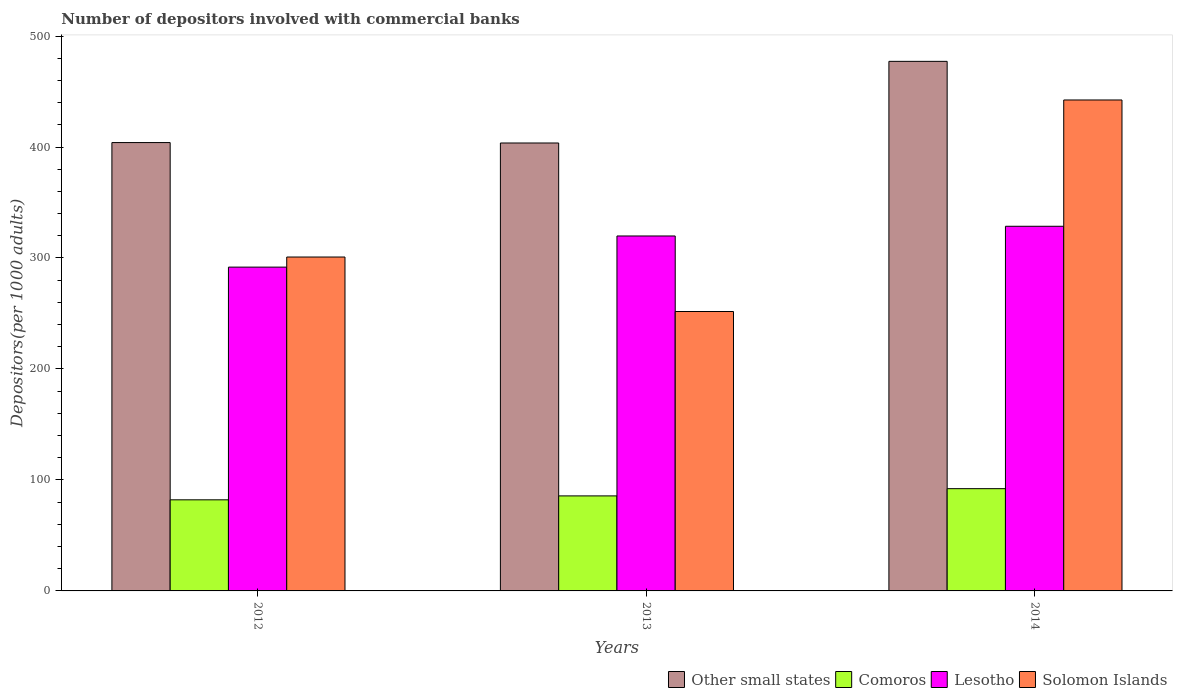Are the number of bars per tick equal to the number of legend labels?
Keep it short and to the point. Yes. Are the number of bars on each tick of the X-axis equal?
Your answer should be very brief. Yes. What is the label of the 2nd group of bars from the left?
Keep it short and to the point. 2013. In how many cases, is the number of bars for a given year not equal to the number of legend labels?
Keep it short and to the point. 0. What is the number of depositors involved with commercial banks in Solomon Islands in 2012?
Keep it short and to the point. 300.87. Across all years, what is the maximum number of depositors involved with commercial banks in Solomon Islands?
Provide a succinct answer. 442.39. Across all years, what is the minimum number of depositors involved with commercial banks in Lesotho?
Give a very brief answer. 291.78. In which year was the number of depositors involved with commercial banks in Comoros maximum?
Offer a very short reply. 2014. In which year was the number of depositors involved with commercial banks in Other small states minimum?
Offer a very short reply. 2013. What is the total number of depositors involved with commercial banks in Lesotho in the graph?
Give a very brief answer. 940.21. What is the difference between the number of depositors involved with commercial banks in Comoros in 2013 and that in 2014?
Give a very brief answer. -6.52. What is the difference between the number of depositors involved with commercial banks in Solomon Islands in 2012 and the number of depositors involved with commercial banks in Lesotho in 2013?
Provide a succinct answer. -18.97. What is the average number of depositors involved with commercial banks in Other small states per year?
Your answer should be compact. 428.28. In the year 2013, what is the difference between the number of depositors involved with commercial banks in Solomon Islands and number of depositors involved with commercial banks in Other small states?
Your response must be concise. -151.85. What is the ratio of the number of depositors involved with commercial banks in Lesotho in 2012 to that in 2014?
Your answer should be compact. 0.89. Is the number of depositors involved with commercial banks in Comoros in 2012 less than that in 2013?
Your answer should be compact. Yes. Is the difference between the number of depositors involved with commercial banks in Solomon Islands in 2013 and 2014 greater than the difference between the number of depositors involved with commercial banks in Other small states in 2013 and 2014?
Provide a short and direct response. No. What is the difference between the highest and the second highest number of depositors involved with commercial banks in Other small states?
Provide a short and direct response. 73.18. What is the difference between the highest and the lowest number of depositors involved with commercial banks in Other small states?
Offer a terse response. 73.56. Is the sum of the number of depositors involved with commercial banks in Comoros in 2012 and 2014 greater than the maximum number of depositors involved with commercial banks in Lesotho across all years?
Your response must be concise. No. Is it the case that in every year, the sum of the number of depositors involved with commercial banks in Other small states and number of depositors involved with commercial banks in Lesotho is greater than the sum of number of depositors involved with commercial banks in Solomon Islands and number of depositors involved with commercial banks in Comoros?
Provide a succinct answer. No. What does the 4th bar from the left in 2014 represents?
Provide a succinct answer. Solomon Islands. What does the 1st bar from the right in 2013 represents?
Ensure brevity in your answer.  Solomon Islands. Are all the bars in the graph horizontal?
Provide a succinct answer. No. How many years are there in the graph?
Your answer should be compact. 3. What is the difference between two consecutive major ticks on the Y-axis?
Provide a short and direct response. 100. Does the graph contain grids?
Your response must be concise. No. Where does the legend appear in the graph?
Offer a terse response. Bottom right. How many legend labels are there?
Your answer should be very brief. 4. How are the legend labels stacked?
Make the answer very short. Horizontal. What is the title of the graph?
Ensure brevity in your answer.  Number of depositors involved with commercial banks. What is the label or title of the Y-axis?
Provide a succinct answer. Depositors(per 1000 adults). What is the Depositors(per 1000 adults) of Other small states in 2012?
Offer a very short reply. 404.02. What is the Depositors(per 1000 adults) of Comoros in 2012?
Ensure brevity in your answer.  82.09. What is the Depositors(per 1000 adults) of Lesotho in 2012?
Ensure brevity in your answer.  291.78. What is the Depositors(per 1000 adults) of Solomon Islands in 2012?
Offer a very short reply. 300.87. What is the Depositors(per 1000 adults) in Other small states in 2013?
Give a very brief answer. 403.64. What is the Depositors(per 1000 adults) of Comoros in 2013?
Your response must be concise. 85.63. What is the Depositors(per 1000 adults) in Lesotho in 2013?
Make the answer very short. 319.84. What is the Depositors(per 1000 adults) in Solomon Islands in 2013?
Provide a succinct answer. 251.79. What is the Depositors(per 1000 adults) of Other small states in 2014?
Keep it short and to the point. 477.2. What is the Depositors(per 1000 adults) of Comoros in 2014?
Your response must be concise. 92.15. What is the Depositors(per 1000 adults) in Lesotho in 2014?
Offer a very short reply. 328.59. What is the Depositors(per 1000 adults) of Solomon Islands in 2014?
Make the answer very short. 442.39. Across all years, what is the maximum Depositors(per 1000 adults) of Other small states?
Provide a short and direct response. 477.2. Across all years, what is the maximum Depositors(per 1000 adults) in Comoros?
Ensure brevity in your answer.  92.15. Across all years, what is the maximum Depositors(per 1000 adults) in Lesotho?
Your answer should be compact. 328.59. Across all years, what is the maximum Depositors(per 1000 adults) of Solomon Islands?
Your answer should be very brief. 442.39. Across all years, what is the minimum Depositors(per 1000 adults) of Other small states?
Give a very brief answer. 403.64. Across all years, what is the minimum Depositors(per 1000 adults) of Comoros?
Provide a short and direct response. 82.09. Across all years, what is the minimum Depositors(per 1000 adults) in Lesotho?
Give a very brief answer. 291.78. Across all years, what is the minimum Depositors(per 1000 adults) of Solomon Islands?
Provide a succinct answer. 251.79. What is the total Depositors(per 1000 adults) of Other small states in the graph?
Your answer should be compact. 1284.85. What is the total Depositors(per 1000 adults) of Comoros in the graph?
Keep it short and to the point. 259.87. What is the total Depositors(per 1000 adults) in Lesotho in the graph?
Your answer should be compact. 940.21. What is the total Depositors(per 1000 adults) of Solomon Islands in the graph?
Your answer should be very brief. 995.05. What is the difference between the Depositors(per 1000 adults) of Other small states in 2012 and that in 2013?
Make the answer very short. 0.38. What is the difference between the Depositors(per 1000 adults) in Comoros in 2012 and that in 2013?
Offer a very short reply. -3.54. What is the difference between the Depositors(per 1000 adults) of Lesotho in 2012 and that in 2013?
Keep it short and to the point. -28.06. What is the difference between the Depositors(per 1000 adults) of Solomon Islands in 2012 and that in 2013?
Your response must be concise. 49.08. What is the difference between the Depositors(per 1000 adults) of Other small states in 2012 and that in 2014?
Keep it short and to the point. -73.18. What is the difference between the Depositors(per 1000 adults) of Comoros in 2012 and that in 2014?
Keep it short and to the point. -10.06. What is the difference between the Depositors(per 1000 adults) in Lesotho in 2012 and that in 2014?
Provide a short and direct response. -36.8. What is the difference between the Depositors(per 1000 adults) in Solomon Islands in 2012 and that in 2014?
Provide a short and direct response. -141.52. What is the difference between the Depositors(per 1000 adults) in Other small states in 2013 and that in 2014?
Give a very brief answer. -73.56. What is the difference between the Depositors(per 1000 adults) of Comoros in 2013 and that in 2014?
Provide a short and direct response. -6.52. What is the difference between the Depositors(per 1000 adults) in Lesotho in 2013 and that in 2014?
Keep it short and to the point. -8.74. What is the difference between the Depositors(per 1000 adults) of Solomon Islands in 2013 and that in 2014?
Provide a short and direct response. -190.6. What is the difference between the Depositors(per 1000 adults) of Other small states in 2012 and the Depositors(per 1000 adults) of Comoros in 2013?
Offer a terse response. 318.39. What is the difference between the Depositors(per 1000 adults) in Other small states in 2012 and the Depositors(per 1000 adults) in Lesotho in 2013?
Offer a very short reply. 84.17. What is the difference between the Depositors(per 1000 adults) in Other small states in 2012 and the Depositors(per 1000 adults) in Solomon Islands in 2013?
Make the answer very short. 152.23. What is the difference between the Depositors(per 1000 adults) in Comoros in 2012 and the Depositors(per 1000 adults) in Lesotho in 2013?
Make the answer very short. -237.75. What is the difference between the Depositors(per 1000 adults) of Comoros in 2012 and the Depositors(per 1000 adults) of Solomon Islands in 2013?
Provide a short and direct response. -169.7. What is the difference between the Depositors(per 1000 adults) in Lesotho in 2012 and the Depositors(per 1000 adults) in Solomon Islands in 2013?
Offer a terse response. 39.99. What is the difference between the Depositors(per 1000 adults) in Other small states in 2012 and the Depositors(per 1000 adults) in Comoros in 2014?
Provide a short and direct response. 311.87. What is the difference between the Depositors(per 1000 adults) in Other small states in 2012 and the Depositors(per 1000 adults) in Lesotho in 2014?
Keep it short and to the point. 75.43. What is the difference between the Depositors(per 1000 adults) in Other small states in 2012 and the Depositors(per 1000 adults) in Solomon Islands in 2014?
Ensure brevity in your answer.  -38.37. What is the difference between the Depositors(per 1000 adults) of Comoros in 2012 and the Depositors(per 1000 adults) of Lesotho in 2014?
Your response must be concise. -246.49. What is the difference between the Depositors(per 1000 adults) in Comoros in 2012 and the Depositors(per 1000 adults) in Solomon Islands in 2014?
Provide a succinct answer. -360.3. What is the difference between the Depositors(per 1000 adults) of Lesotho in 2012 and the Depositors(per 1000 adults) of Solomon Islands in 2014?
Your answer should be very brief. -150.61. What is the difference between the Depositors(per 1000 adults) in Other small states in 2013 and the Depositors(per 1000 adults) in Comoros in 2014?
Provide a succinct answer. 311.49. What is the difference between the Depositors(per 1000 adults) in Other small states in 2013 and the Depositors(per 1000 adults) in Lesotho in 2014?
Your answer should be compact. 75.05. What is the difference between the Depositors(per 1000 adults) in Other small states in 2013 and the Depositors(per 1000 adults) in Solomon Islands in 2014?
Make the answer very short. -38.75. What is the difference between the Depositors(per 1000 adults) in Comoros in 2013 and the Depositors(per 1000 adults) in Lesotho in 2014?
Your answer should be compact. -242.96. What is the difference between the Depositors(per 1000 adults) in Comoros in 2013 and the Depositors(per 1000 adults) in Solomon Islands in 2014?
Give a very brief answer. -356.76. What is the difference between the Depositors(per 1000 adults) of Lesotho in 2013 and the Depositors(per 1000 adults) of Solomon Islands in 2014?
Your answer should be very brief. -122.55. What is the average Depositors(per 1000 adults) of Other small states per year?
Your response must be concise. 428.28. What is the average Depositors(per 1000 adults) in Comoros per year?
Give a very brief answer. 86.62. What is the average Depositors(per 1000 adults) of Lesotho per year?
Give a very brief answer. 313.4. What is the average Depositors(per 1000 adults) of Solomon Islands per year?
Give a very brief answer. 331.68. In the year 2012, what is the difference between the Depositors(per 1000 adults) of Other small states and Depositors(per 1000 adults) of Comoros?
Your response must be concise. 321.93. In the year 2012, what is the difference between the Depositors(per 1000 adults) in Other small states and Depositors(per 1000 adults) in Lesotho?
Give a very brief answer. 112.24. In the year 2012, what is the difference between the Depositors(per 1000 adults) in Other small states and Depositors(per 1000 adults) in Solomon Islands?
Ensure brevity in your answer.  103.14. In the year 2012, what is the difference between the Depositors(per 1000 adults) in Comoros and Depositors(per 1000 adults) in Lesotho?
Your response must be concise. -209.69. In the year 2012, what is the difference between the Depositors(per 1000 adults) of Comoros and Depositors(per 1000 adults) of Solomon Islands?
Offer a very short reply. -218.78. In the year 2012, what is the difference between the Depositors(per 1000 adults) of Lesotho and Depositors(per 1000 adults) of Solomon Islands?
Keep it short and to the point. -9.09. In the year 2013, what is the difference between the Depositors(per 1000 adults) of Other small states and Depositors(per 1000 adults) of Comoros?
Ensure brevity in your answer.  318.01. In the year 2013, what is the difference between the Depositors(per 1000 adults) in Other small states and Depositors(per 1000 adults) in Lesotho?
Offer a terse response. 83.8. In the year 2013, what is the difference between the Depositors(per 1000 adults) of Other small states and Depositors(per 1000 adults) of Solomon Islands?
Provide a succinct answer. 151.85. In the year 2013, what is the difference between the Depositors(per 1000 adults) of Comoros and Depositors(per 1000 adults) of Lesotho?
Your answer should be very brief. -234.21. In the year 2013, what is the difference between the Depositors(per 1000 adults) in Comoros and Depositors(per 1000 adults) in Solomon Islands?
Offer a terse response. -166.16. In the year 2013, what is the difference between the Depositors(per 1000 adults) in Lesotho and Depositors(per 1000 adults) in Solomon Islands?
Your answer should be compact. 68.05. In the year 2014, what is the difference between the Depositors(per 1000 adults) of Other small states and Depositors(per 1000 adults) of Comoros?
Provide a short and direct response. 385.05. In the year 2014, what is the difference between the Depositors(per 1000 adults) in Other small states and Depositors(per 1000 adults) in Lesotho?
Make the answer very short. 148.62. In the year 2014, what is the difference between the Depositors(per 1000 adults) in Other small states and Depositors(per 1000 adults) in Solomon Islands?
Offer a very short reply. 34.81. In the year 2014, what is the difference between the Depositors(per 1000 adults) in Comoros and Depositors(per 1000 adults) in Lesotho?
Keep it short and to the point. -236.44. In the year 2014, what is the difference between the Depositors(per 1000 adults) of Comoros and Depositors(per 1000 adults) of Solomon Islands?
Your answer should be very brief. -350.24. In the year 2014, what is the difference between the Depositors(per 1000 adults) of Lesotho and Depositors(per 1000 adults) of Solomon Islands?
Offer a terse response. -113.81. What is the ratio of the Depositors(per 1000 adults) in Comoros in 2012 to that in 2013?
Your answer should be compact. 0.96. What is the ratio of the Depositors(per 1000 adults) in Lesotho in 2012 to that in 2013?
Keep it short and to the point. 0.91. What is the ratio of the Depositors(per 1000 adults) in Solomon Islands in 2012 to that in 2013?
Make the answer very short. 1.19. What is the ratio of the Depositors(per 1000 adults) in Other small states in 2012 to that in 2014?
Your response must be concise. 0.85. What is the ratio of the Depositors(per 1000 adults) in Comoros in 2012 to that in 2014?
Your answer should be very brief. 0.89. What is the ratio of the Depositors(per 1000 adults) of Lesotho in 2012 to that in 2014?
Provide a succinct answer. 0.89. What is the ratio of the Depositors(per 1000 adults) in Solomon Islands in 2012 to that in 2014?
Your answer should be compact. 0.68. What is the ratio of the Depositors(per 1000 adults) in Other small states in 2013 to that in 2014?
Offer a terse response. 0.85. What is the ratio of the Depositors(per 1000 adults) of Comoros in 2013 to that in 2014?
Provide a short and direct response. 0.93. What is the ratio of the Depositors(per 1000 adults) in Lesotho in 2013 to that in 2014?
Offer a very short reply. 0.97. What is the ratio of the Depositors(per 1000 adults) in Solomon Islands in 2013 to that in 2014?
Ensure brevity in your answer.  0.57. What is the difference between the highest and the second highest Depositors(per 1000 adults) of Other small states?
Your answer should be compact. 73.18. What is the difference between the highest and the second highest Depositors(per 1000 adults) in Comoros?
Offer a terse response. 6.52. What is the difference between the highest and the second highest Depositors(per 1000 adults) in Lesotho?
Your answer should be very brief. 8.74. What is the difference between the highest and the second highest Depositors(per 1000 adults) in Solomon Islands?
Your response must be concise. 141.52. What is the difference between the highest and the lowest Depositors(per 1000 adults) of Other small states?
Make the answer very short. 73.56. What is the difference between the highest and the lowest Depositors(per 1000 adults) of Comoros?
Give a very brief answer. 10.06. What is the difference between the highest and the lowest Depositors(per 1000 adults) of Lesotho?
Give a very brief answer. 36.8. What is the difference between the highest and the lowest Depositors(per 1000 adults) of Solomon Islands?
Provide a succinct answer. 190.6. 